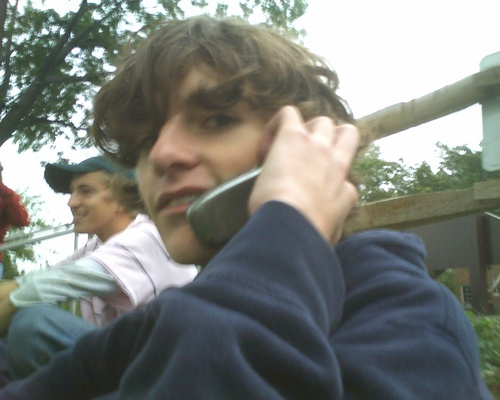Describe the objects in this image and their specific colors. I can see people in gray, black, and darkblue tones, people in gray, lightgray, darkgray, and black tones, and cell phone in gray and black tones in this image. 